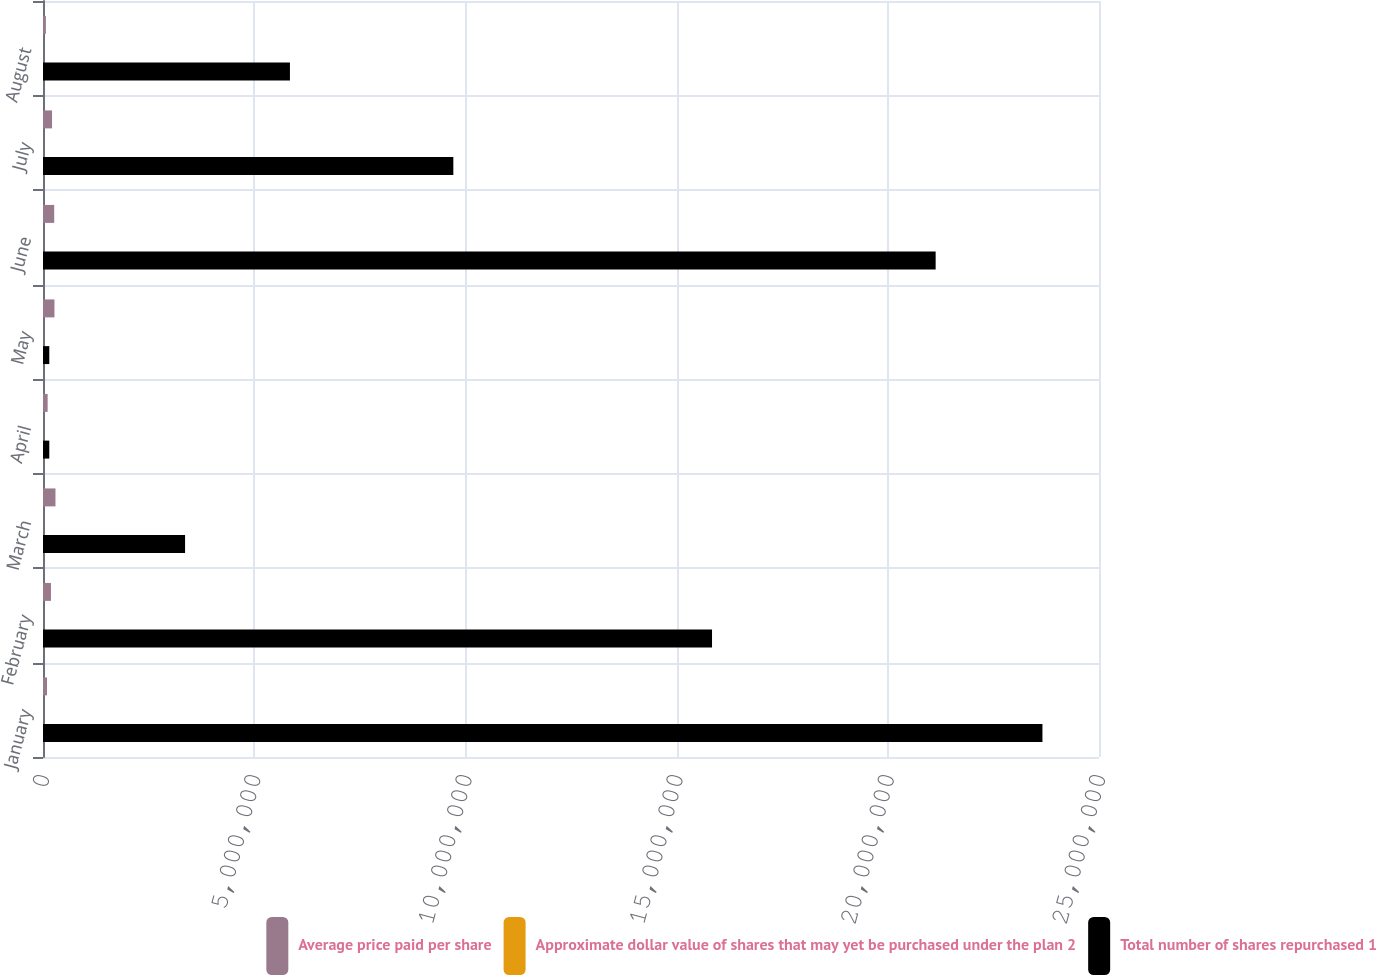Convert chart. <chart><loc_0><loc_0><loc_500><loc_500><stacked_bar_chart><ecel><fcel>January<fcel>February<fcel>March<fcel>April<fcel>May<fcel>June<fcel>July<fcel>August<nl><fcel>Average price paid per share<fcel>94818<fcel>188199<fcel>295463<fcel>109670<fcel>271395<fcel>265103<fcel>213925<fcel>68536<nl><fcel>Approximate dollar value of shares that may yet be purchased under the plan 2<fcel>41.44<fcel>41.56<fcel>42.22<fcel>46.06<fcel>49.32<fcel>52.03<fcel>53.38<fcel>56.44<nl><fcel>Total number of shares repurchased 1<fcel>2.36609e+07<fcel>1.58387e+07<fcel>3.36352e+06<fcel>148934<fcel>148934<fcel>2.11328e+07<fcel>9.71437e+06<fcel>5.8462e+06<nl></chart> 